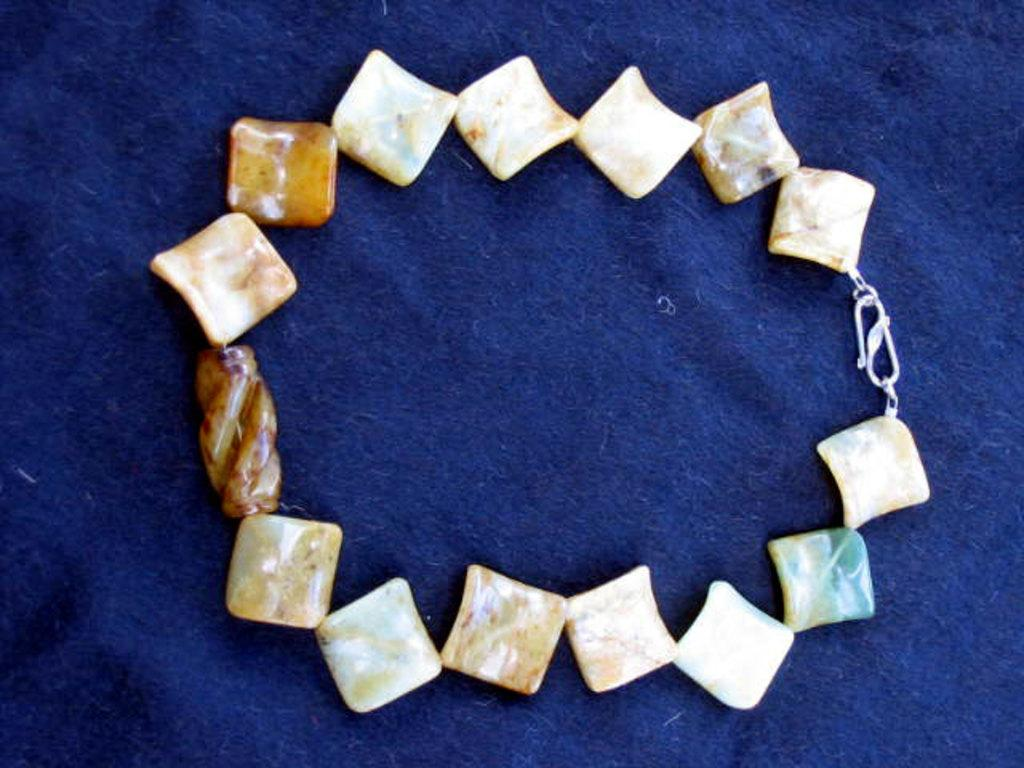What is the main subject of the image? The main subject of the image is a chain of pebbles. What is the color of the cloth at the bottom of the image? The cloth at the bottom of the image is blue. How many toes can be seen on the pebbles in the image? There are no toes present on the pebbles in the image, as pebbles are inanimate objects and do not have body parts like toes. 